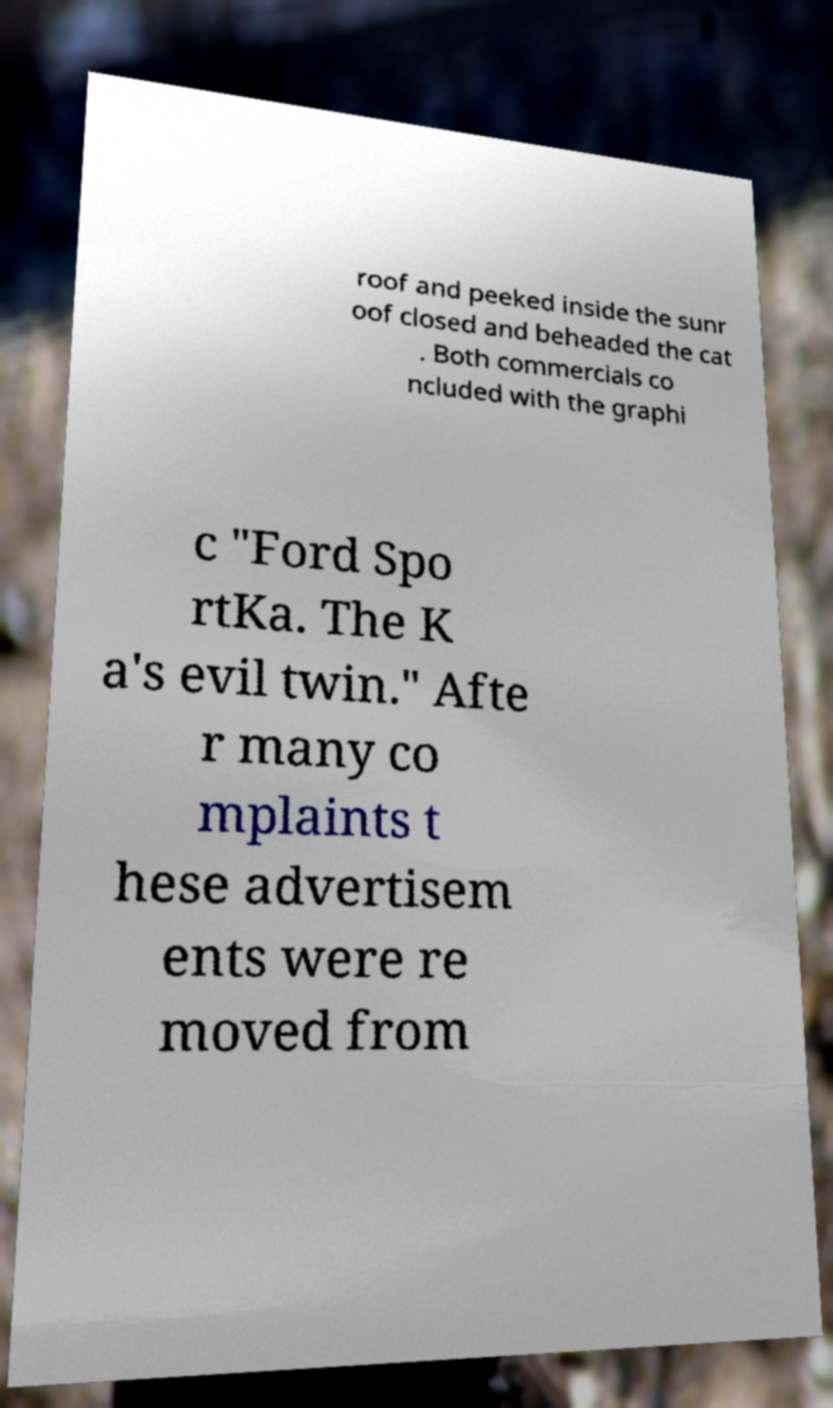There's text embedded in this image that I need extracted. Can you transcribe it verbatim? roof and peeked inside the sunr oof closed and beheaded the cat . Both commercials co ncluded with the graphi c "Ford Spo rtKa. The K a's evil twin." Afte r many co mplaints t hese advertisem ents were re moved from 